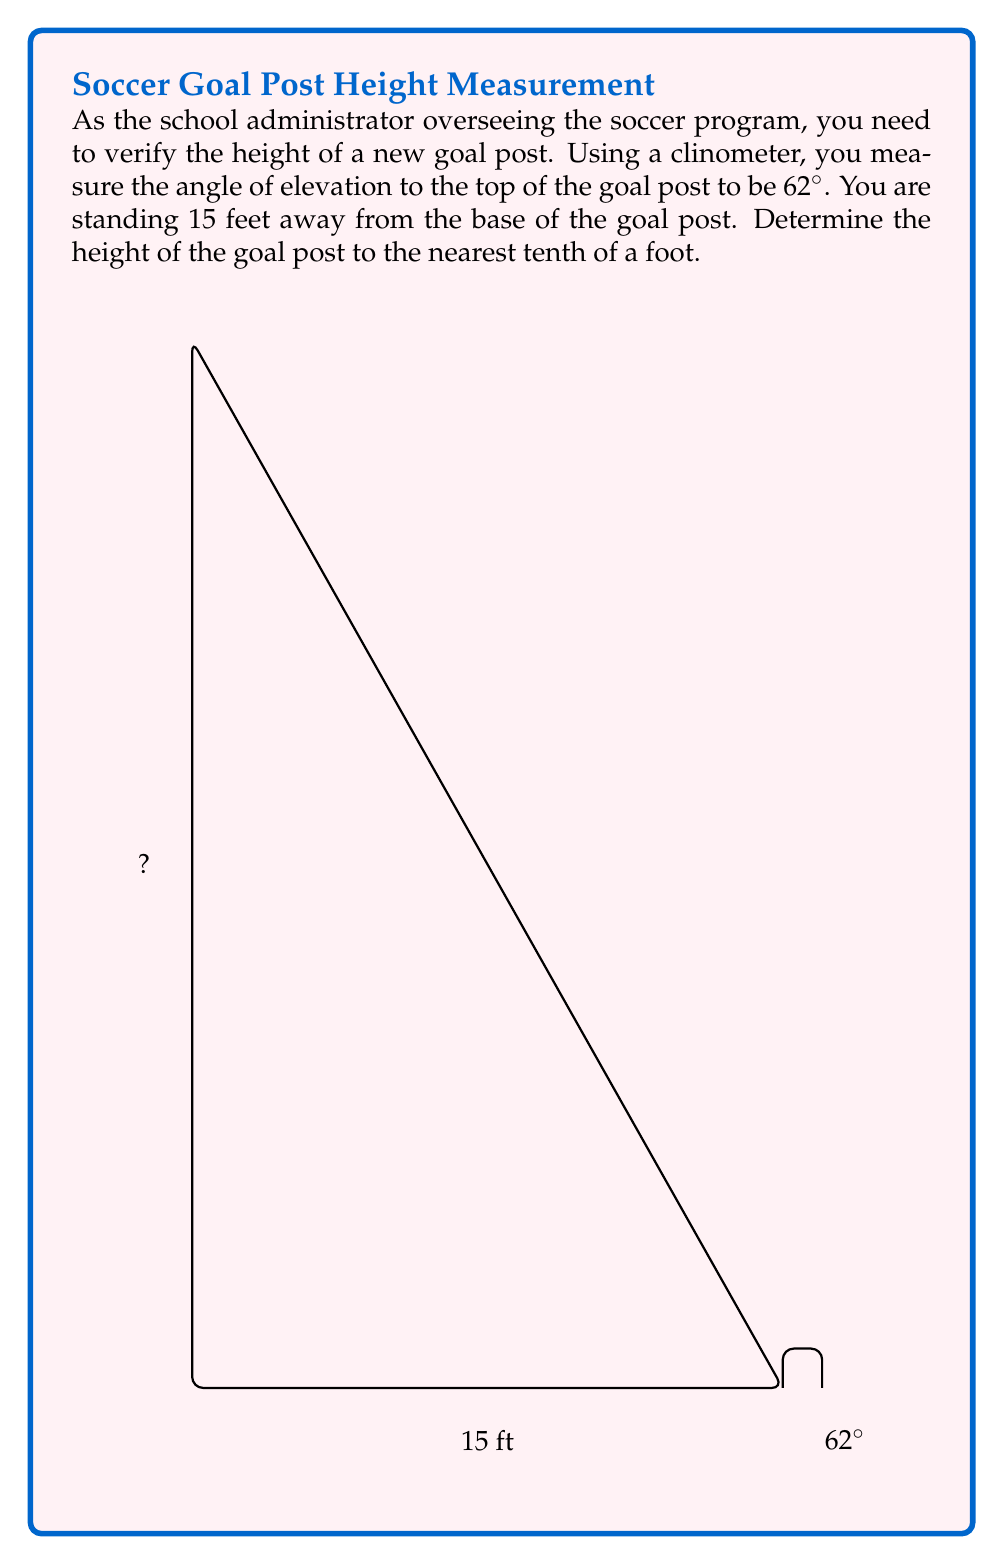Could you help me with this problem? To solve this problem, we'll use trigonometry, specifically the tangent function. Let's break it down step-by-step:

1) In a right triangle, tangent of an angle is the ratio of the opposite side to the adjacent side.

2) In this case:
   - The angle of elevation is 62°
   - The adjacent side (distance from you to the base of the goal post) is 15 feet
   - The opposite side is the height of the goal post, which we need to find

3) Let's call the height $h$. We can set up the equation:

   $$\tan(62°) = \frac{h}{15}$$

4) To solve for $h$, we multiply both sides by 15:

   $$15 \cdot \tan(62°) = h$$

5) Now, let's calculate:
   
   $$h = 15 \cdot \tan(62°)$$
   $$h = 15 \cdot 1.88073$$
   $$h = 28.21095$$

6) Rounding to the nearest tenth:

   $$h \approx 28.2\text{ feet}$$

Therefore, the height of the goal post is approximately 28.2 feet.
Answer: $28.2\text{ feet}$ 